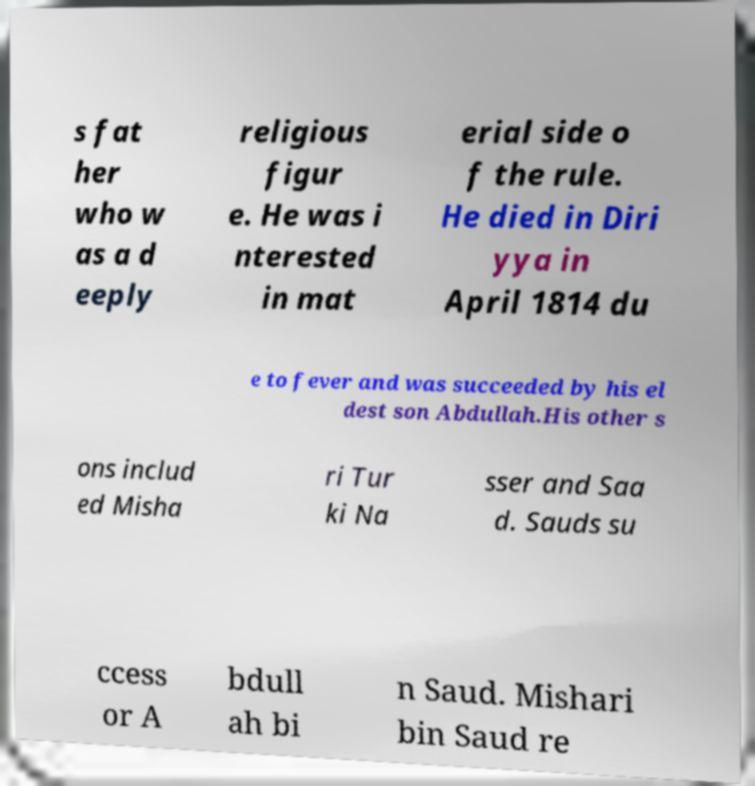Please read and relay the text visible in this image. What does it say? s fat her who w as a d eeply religious figur e. He was i nterested in mat erial side o f the rule. He died in Diri yya in April 1814 du e to fever and was succeeded by his el dest son Abdullah.His other s ons includ ed Misha ri Tur ki Na sser and Saa d. Sauds su ccess or A bdull ah bi n Saud. Mishari bin Saud re 